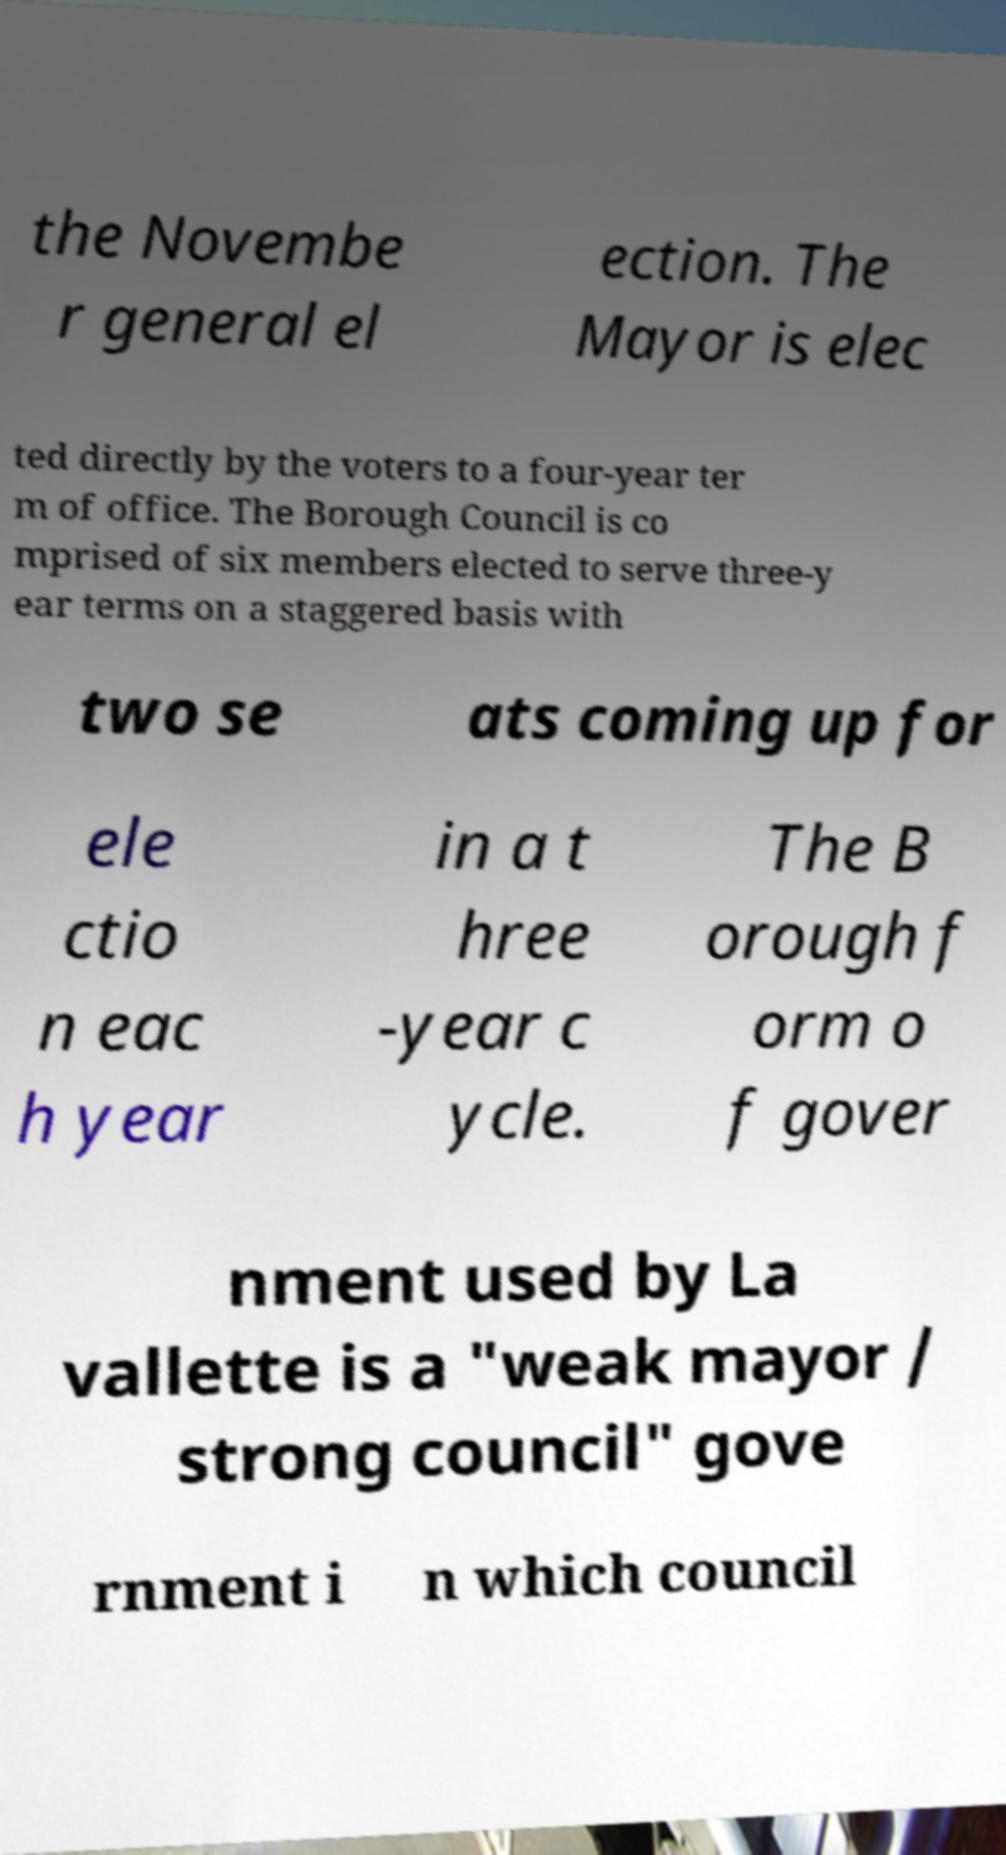What messages or text are displayed in this image? I need them in a readable, typed format. the Novembe r general el ection. The Mayor is elec ted directly by the voters to a four-year ter m of office. The Borough Council is co mprised of six members elected to serve three-y ear terms on a staggered basis with two se ats coming up for ele ctio n eac h year in a t hree -year c ycle. The B orough f orm o f gover nment used by La vallette is a "weak mayor / strong council" gove rnment i n which council 